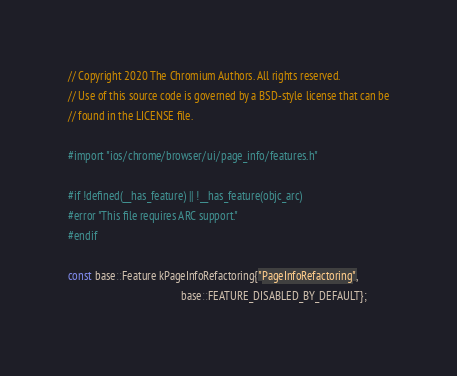Convert code to text. <code><loc_0><loc_0><loc_500><loc_500><_ObjectiveC_>// Copyright 2020 The Chromium Authors. All rights reserved.
// Use of this source code is governed by a BSD-style license that can be
// found in the LICENSE file.

#import "ios/chrome/browser/ui/page_info/features.h"

#if !defined(__has_feature) || !__has_feature(objc_arc)
#error "This file requires ARC support."
#endif

const base::Feature kPageInfoRefactoring{"PageInfoRefactoring",
                                         base::FEATURE_DISABLED_BY_DEFAULT};
</code> 